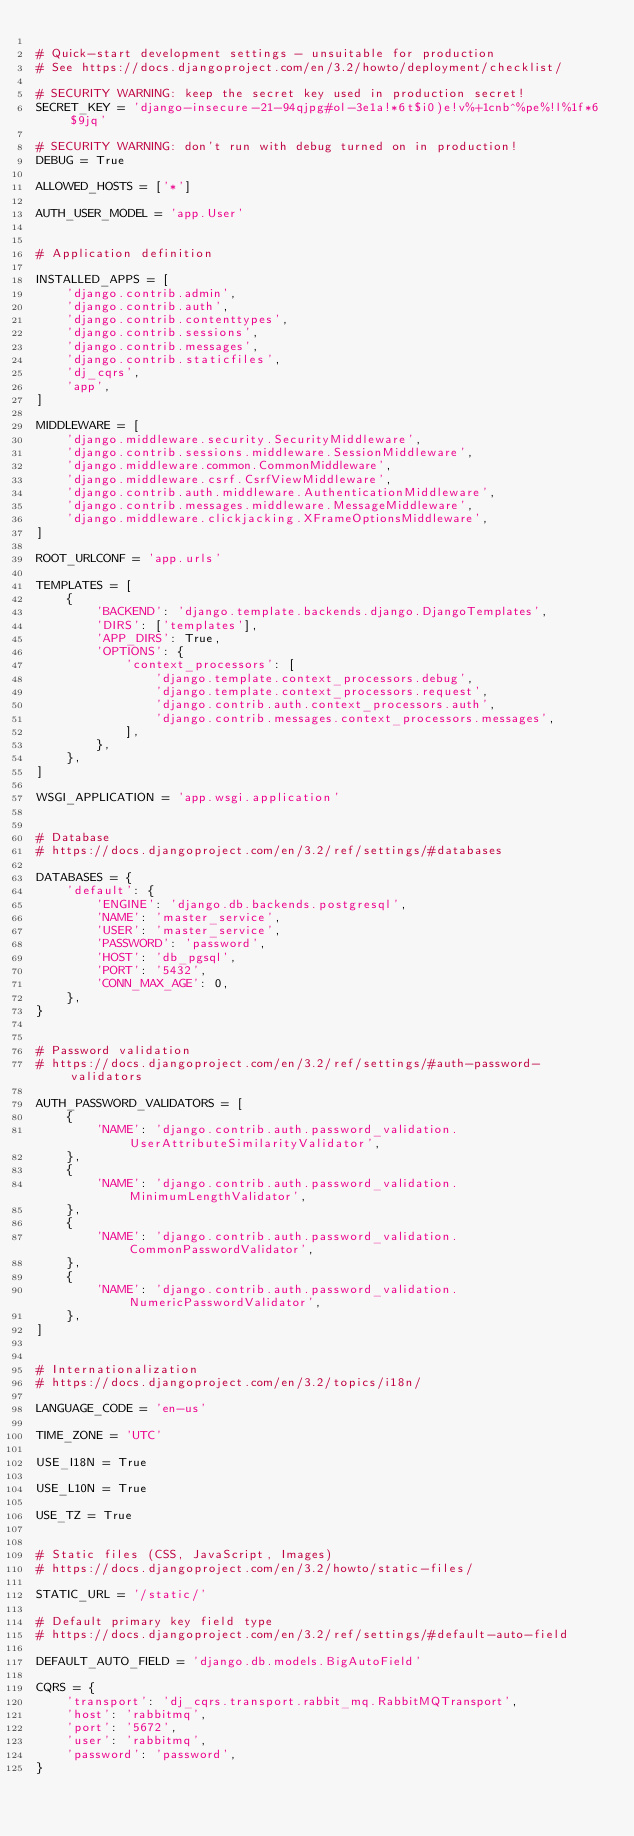Convert code to text. <code><loc_0><loc_0><loc_500><loc_500><_Python_>
# Quick-start development settings - unsuitable for production
# See https://docs.djangoproject.com/en/3.2/howto/deployment/checklist/

# SECURITY WARNING: keep the secret key used in production secret!
SECRET_KEY = 'django-insecure-21-94qjpg#ol-3e1a!*6t$i0)e!v%+1cnb^%pe%!l%1f*6$9jq'

# SECURITY WARNING: don't run with debug turned on in production!
DEBUG = True

ALLOWED_HOSTS = ['*']

AUTH_USER_MODEL = 'app.User'


# Application definition

INSTALLED_APPS = [
    'django.contrib.admin',
    'django.contrib.auth',
    'django.contrib.contenttypes',
    'django.contrib.sessions',
    'django.contrib.messages',
    'django.contrib.staticfiles',
    'dj_cqrs',
    'app',
]

MIDDLEWARE = [
    'django.middleware.security.SecurityMiddleware',
    'django.contrib.sessions.middleware.SessionMiddleware',
    'django.middleware.common.CommonMiddleware',
    'django.middleware.csrf.CsrfViewMiddleware',
    'django.contrib.auth.middleware.AuthenticationMiddleware',
    'django.contrib.messages.middleware.MessageMiddleware',
    'django.middleware.clickjacking.XFrameOptionsMiddleware',
]

ROOT_URLCONF = 'app.urls'

TEMPLATES = [
    {
        'BACKEND': 'django.template.backends.django.DjangoTemplates',
        'DIRS': ['templates'],
        'APP_DIRS': True,
        'OPTIONS': {
            'context_processors': [
                'django.template.context_processors.debug',
                'django.template.context_processors.request',
                'django.contrib.auth.context_processors.auth',
                'django.contrib.messages.context_processors.messages',
            ],
        },
    },
]

WSGI_APPLICATION = 'app.wsgi.application'


# Database
# https://docs.djangoproject.com/en/3.2/ref/settings/#databases

DATABASES = {
    'default': {
        'ENGINE': 'django.db.backends.postgresql',
        'NAME': 'master_service',
        'USER': 'master_service',
        'PASSWORD': 'password',
        'HOST': 'db_pgsql',
        'PORT': '5432',
        'CONN_MAX_AGE': 0,
    },
}


# Password validation
# https://docs.djangoproject.com/en/3.2/ref/settings/#auth-password-validators

AUTH_PASSWORD_VALIDATORS = [
    {
        'NAME': 'django.contrib.auth.password_validation.UserAttributeSimilarityValidator',
    },
    {
        'NAME': 'django.contrib.auth.password_validation.MinimumLengthValidator',
    },
    {
        'NAME': 'django.contrib.auth.password_validation.CommonPasswordValidator',
    },
    {
        'NAME': 'django.contrib.auth.password_validation.NumericPasswordValidator',
    },
]


# Internationalization
# https://docs.djangoproject.com/en/3.2/topics/i18n/

LANGUAGE_CODE = 'en-us'

TIME_ZONE = 'UTC'

USE_I18N = True

USE_L10N = True

USE_TZ = True


# Static files (CSS, JavaScript, Images)
# https://docs.djangoproject.com/en/3.2/howto/static-files/

STATIC_URL = '/static/'

# Default primary key field type
# https://docs.djangoproject.com/en/3.2/ref/settings/#default-auto-field

DEFAULT_AUTO_FIELD = 'django.db.models.BigAutoField'

CQRS = {
    'transport': 'dj_cqrs.transport.rabbit_mq.RabbitMQTransport',
    'host': 'rabbitmq',
    'port': '5672',
    'user': 'rabbitmq',
    'password': 'password',
}
</code> 